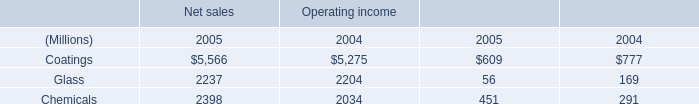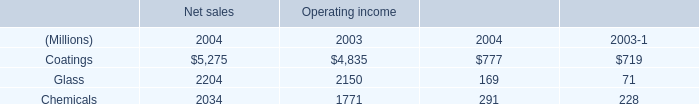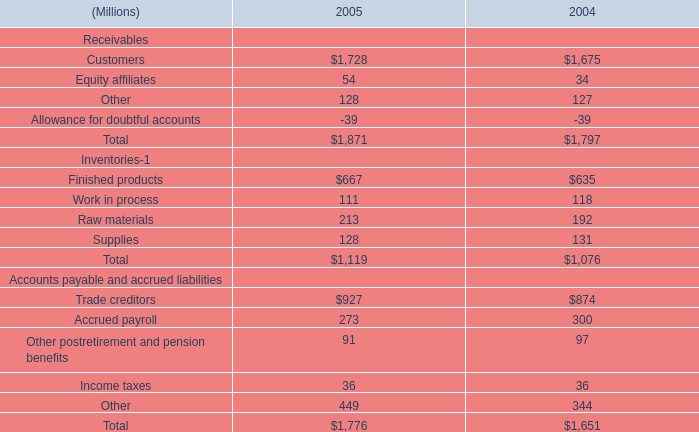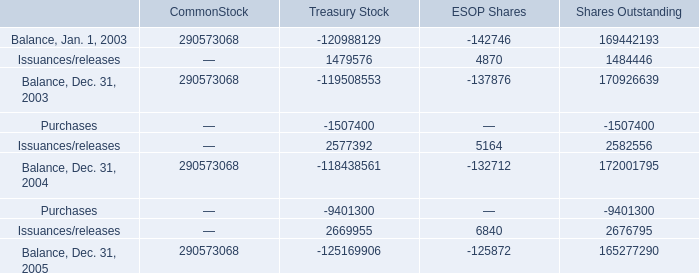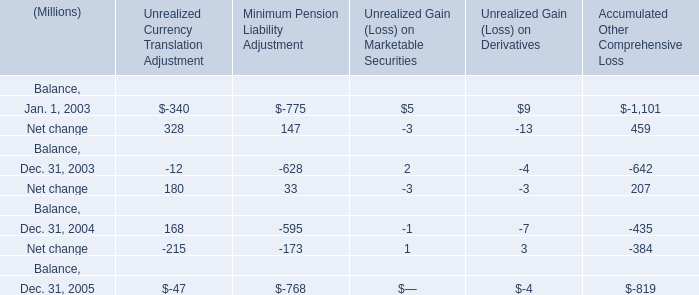What's the sum of Issuances/releases of Treasury Stock, Glass of Net sales 2004, and Issuances/releases of ESOP Shares ? 
Computations: ((1479576.0 + 2204.0) + 6840.0)
Answer: 1488620.0. 